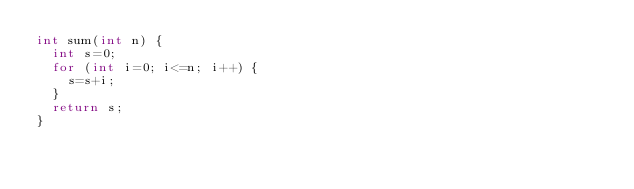<code> <loc_0><loc_0><loc_500><loc_500><_C_>int sum(int n) {
  int s=0;
  for (int i=0; i<=n; i++) {
    s=s+i;
  }
  return s;
}</code> 